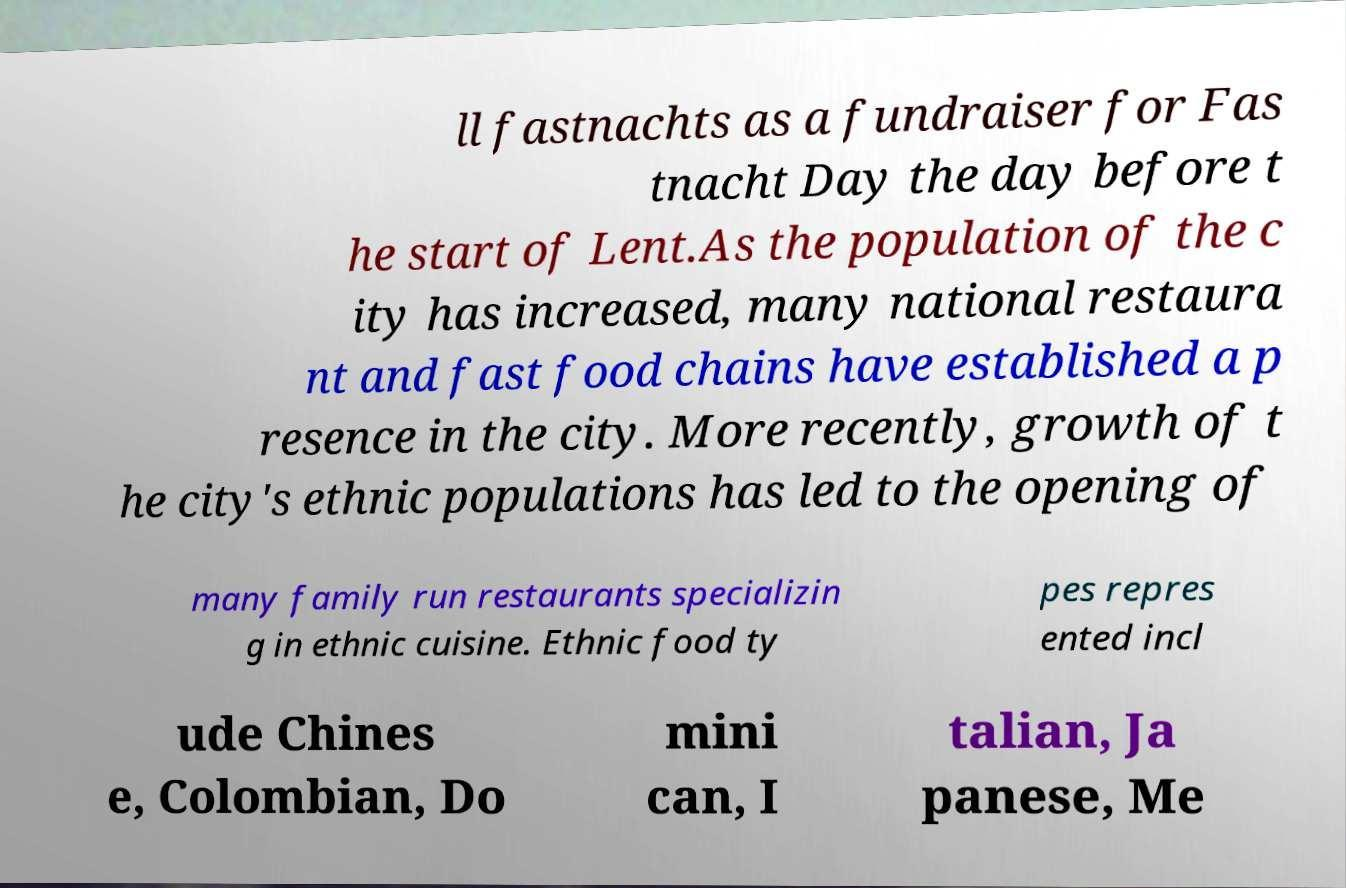Please identify and transcribe the text found in this image. ll fastnachts as a fundraiser for Fas tnacht Day the day before t he start of Lent.As the population of the c ity has increased, many national restaura nt and fast food chains have established a p resence in the city. More recently, growth of t he city's ethnic populations has led to the opening of many family run restaurants specializin g in ethnic cuisine. Ethnic food ty pes repres ented incl ude Chines e, Colombian, Do mini can, I talian, Ja panese, Me 